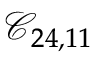Convert formula to latex. <formula><loc_0><loc_0><loc_500><loc_500>\mathcal { C } _ { 2 4 , 1 1 }</formula> 